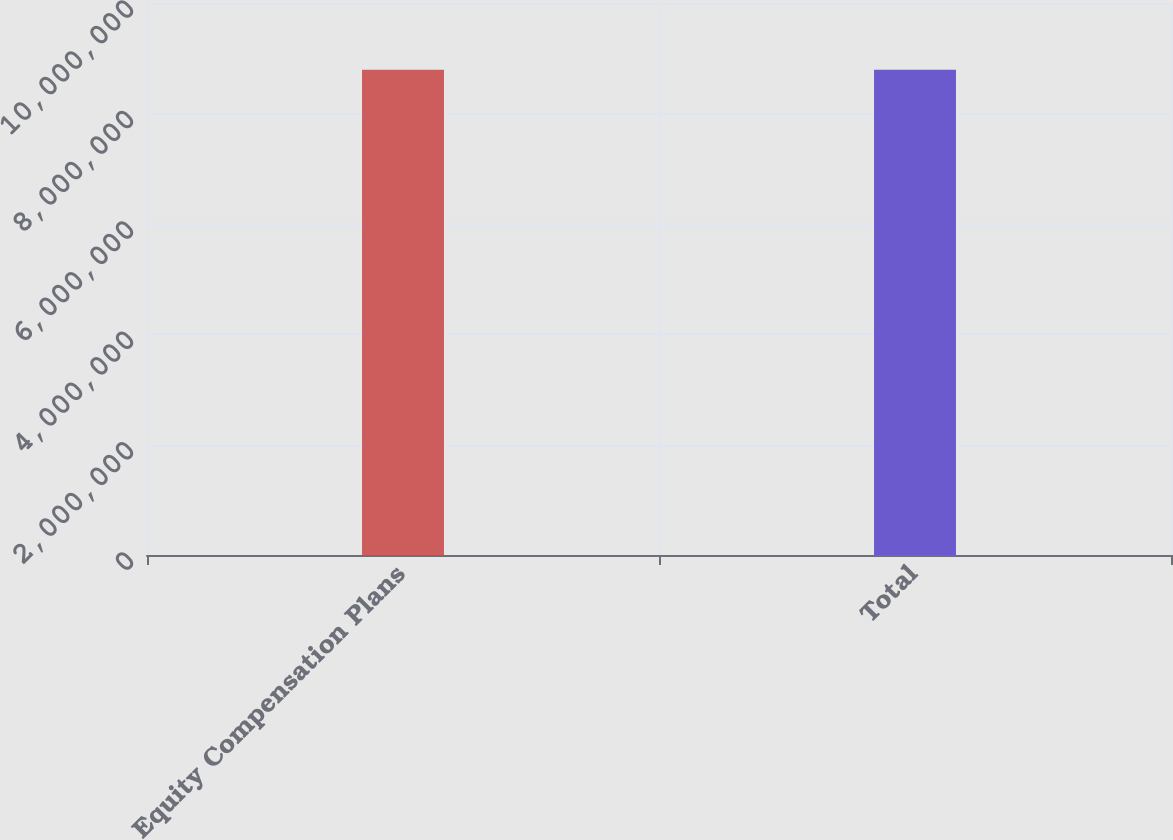Convert chart to OTSL. <chart><loc_0><loc_0><loc_500><loc_500><bar_chart><fcel>Equity Compensation Plans<fcel>Total<nl><fcel>8.78992e+06<fcel>8.78993e+06<nl></chart> 